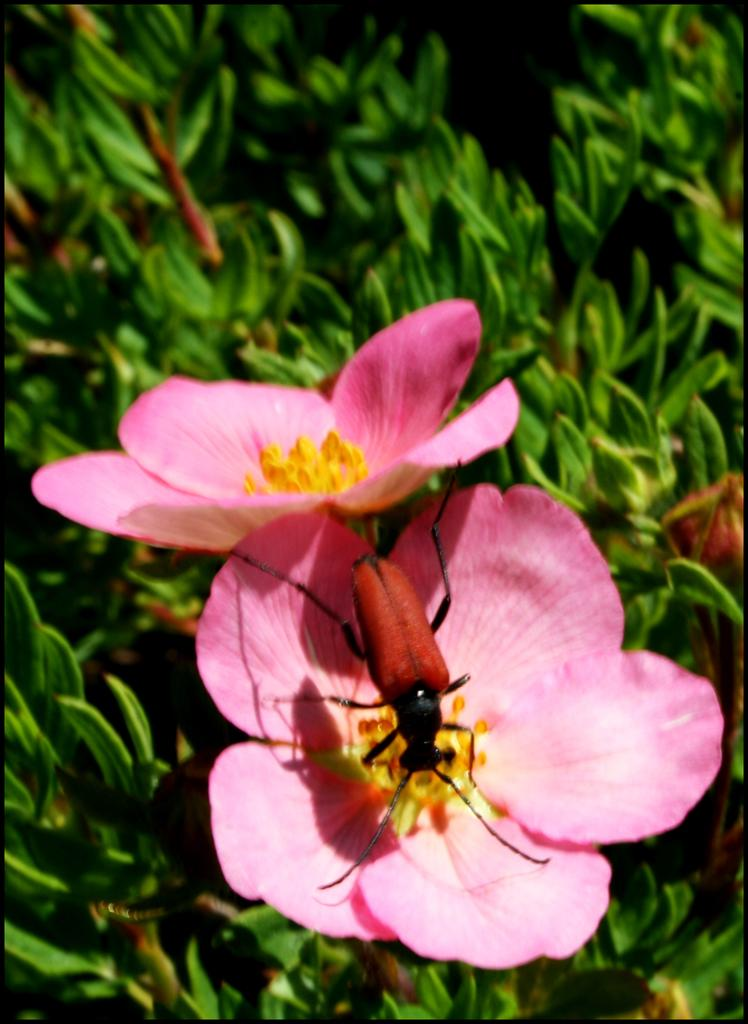What colors are the flowers in the image? The flowers in the image are pink and white. What color are the plants in the image? The plants in the image are green. Can you describe any living organisms present on the flowers? Yes, an insect is present on a flower in the image. What type of card is being used to weigh the flowers in the image? There is no card or scale present in the image, so it is not possible to determine if any weighing is taking place. 